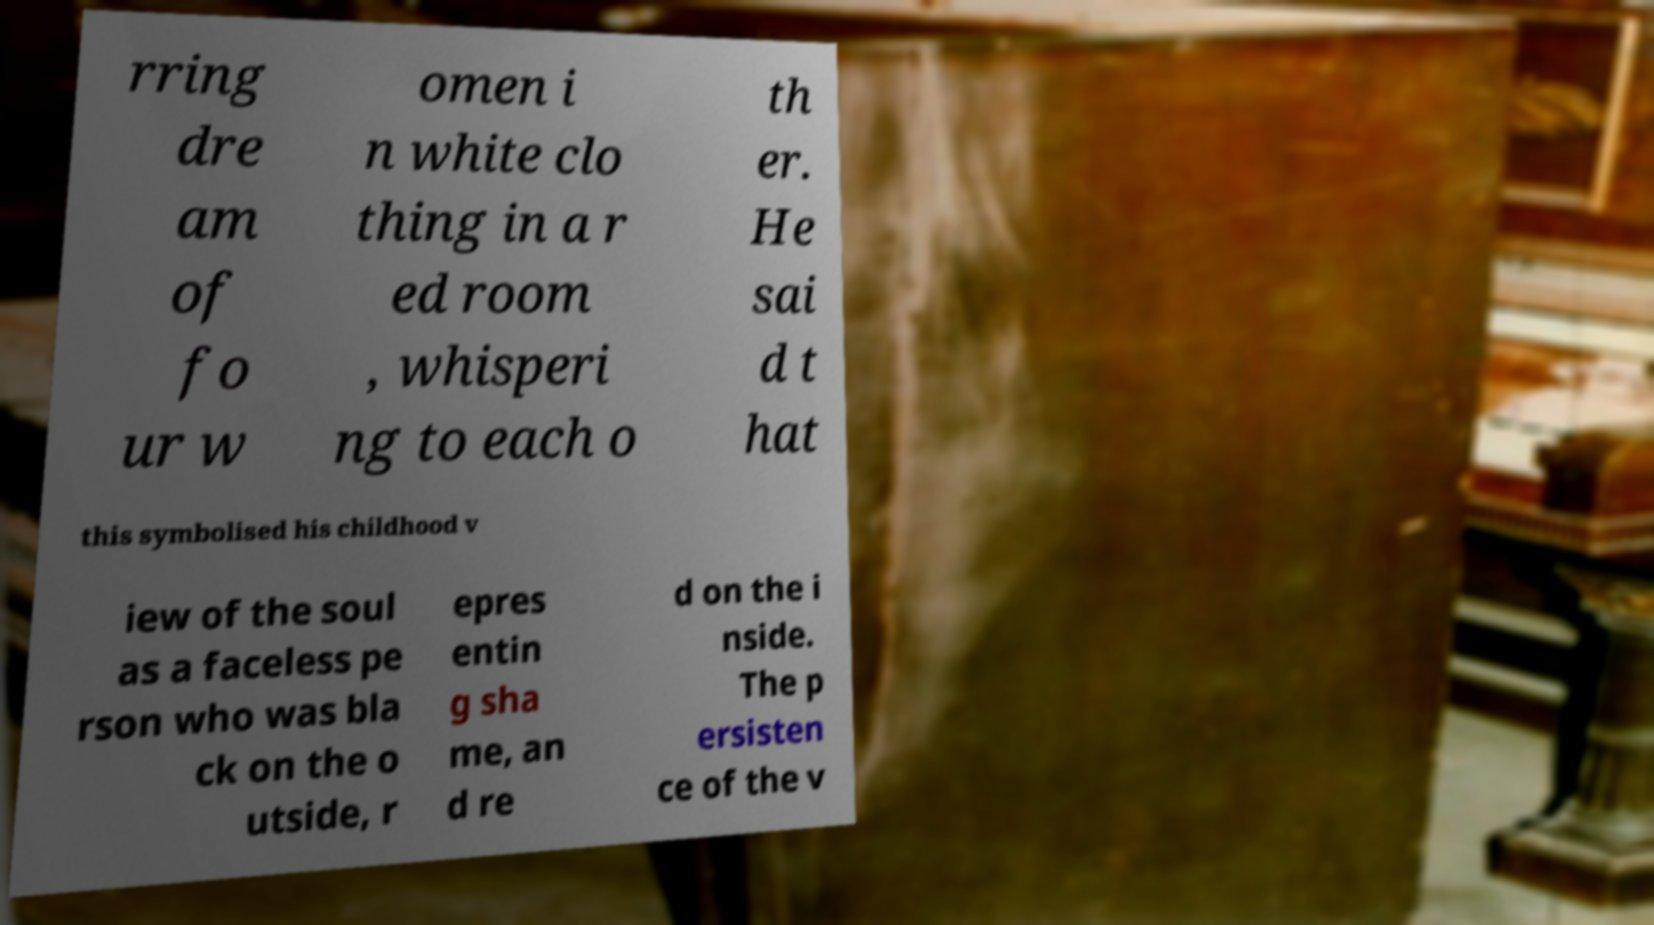Please identify and transcribe the text found in this image. rring dre am of fo ur w omen i n white clo thing in a r ed room , whisperi ng to each o th er. He sai d t hat this symbolised his childhood v iew of the soul as a faceless pe rson who was bla ck on the o utside, r epres entin g sha me, an d re d on the i nside. The p ersisten ce of the v 